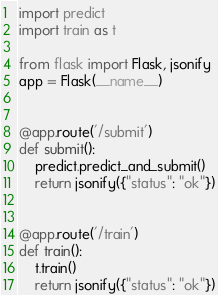Convert code to text. <code><loc_0><loc_0><loc_500><loc_500><_Python_>import predict
import train as t

from flask import Flask, jsonify
app = Flask(__name__)


@app.route('/submit')
def submit():
    predict.predict_and_submit()
    return jsonify({"status": "ok"})


@app.route('/train')
def train():
    t.train()
    return jsonify({"status": "ok"})
</code> 